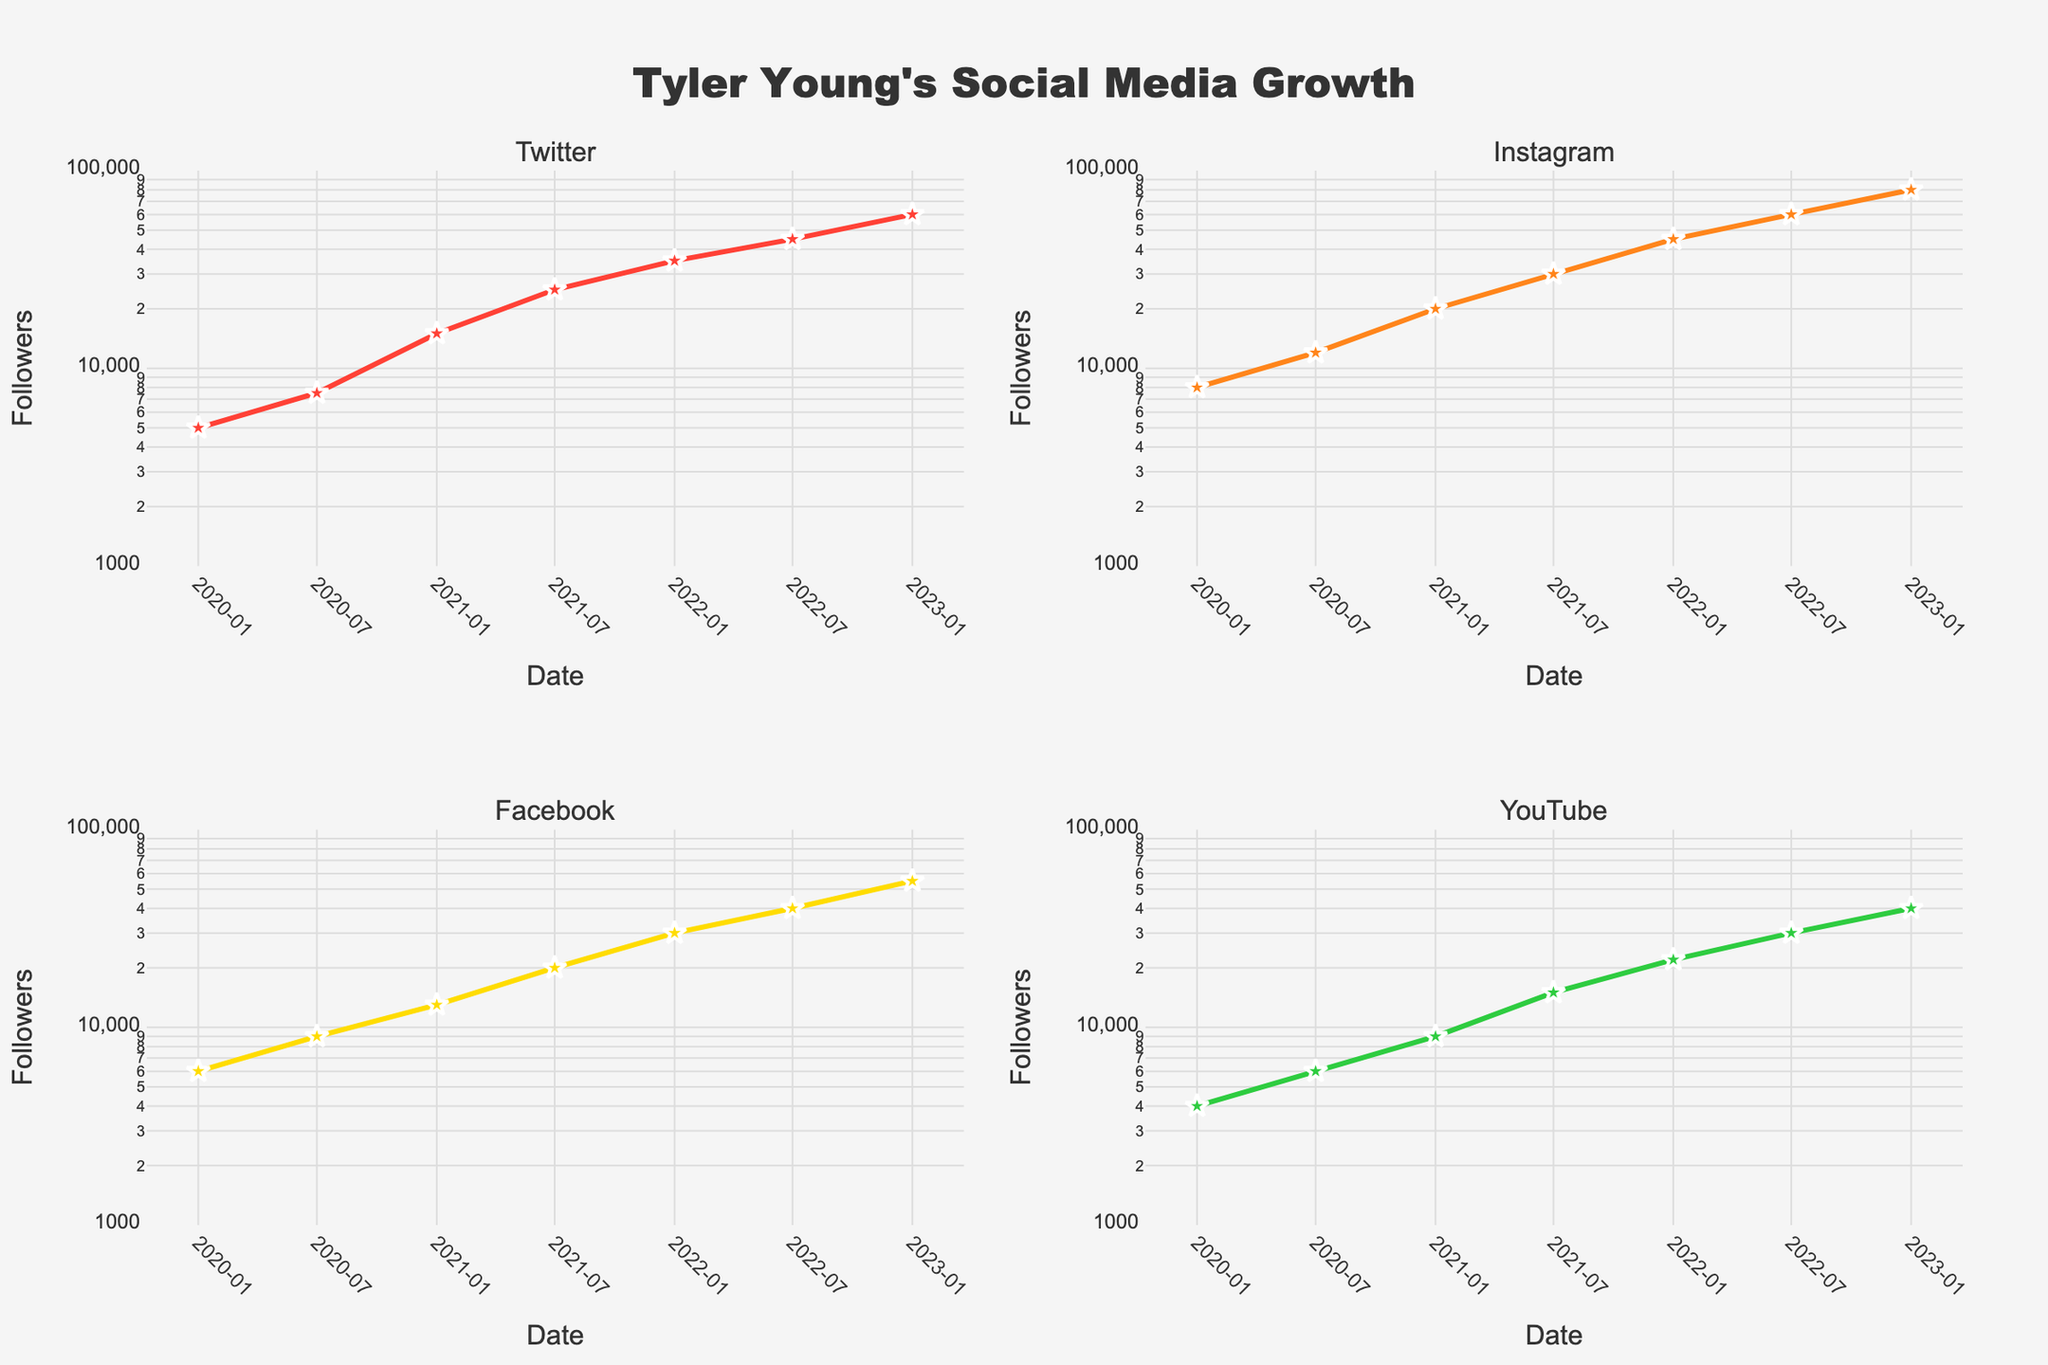How many social media platforms are tracked in the figure? The figure includes subplots for each social media platform, and there are four subplot titles visible on the figure.
Answer: Four Which platform had the highest number of followers in January 2023? By looking at the rightmost data points for January 2023 across all subplots and comparing the values, Instagram had the highest number with 80,000 followers.
Answer: Instagram How has Twitter follower growth trended from 2020 to 2023? Observing the subplot for Twitter, the follower count increased from 5,000 in January 2020 to 60,000 in January 2023. The growth is roughly exponential, as the Y-axis is in logarithmic scale.
Answer: Exponential growth Between Facebook and YouTube, which platform had a faster growth rate from 2021 to 2022? Comparing 2021 to 2022 data points in the respective subplots, Facebook followers increased from 13,000 to 30,000, while YouTube followers increased from 9,000 to 22,000. Calculating the growth rates: Facebook's rate is (30,000 - 13,000)/13,000 ≈ 1.31, and YouTube's rate is (22,000 - 9,000)/9,000 ≈ 1.44. Therefore, YouTube had a faster growth rate.
Answer: YouTube What is the approximate total number of followers across all platforms in January 2022? Summing up the follower counts for January 2022 from each subplot: Twitter (35,000), Instagram (45,000), Facebook (30,000), and YouTube (22,000). Adding them gives 35,000 + 45,000 + 30,000 + 22,000 = 132,000.
Answer: 132,000 Which platform's followers grew by a factor of 3 between July 2020 and January 2023? To find the platforms with a tripling of followers, check each subplot. For Twitter: 7,500 in July 2020 to 60,000 in January 2023 (not tripled). For Instagram: 12,000 to 80,000 (more than tripled). For Facebook: 9,000 to 55,000 (more than tripled). For YouTube: 6,000 to 40,000 (more than tripled). None of the platforms had exactly tripled their followers; they all grew by more than a factor of 3.
Answer: None Did any platform show a linear growth trend on the log scale axis? On a log scale, linear growth appears as an exponential curve. Checking the subplots, Instagram appears to have a more consistent and straighter upward trajectory, indicating an exponential (linear on log) growth pattern.
Answer: Instagram Which platform experienced the greatest increase in followers from July 2022 to January 2023? Comparing the increase in follower counts between these two points: Twitter (45,000 to 60,000), Instagram (60,000 to 80,000), Facebook (40,000 to 55,000), YouTube (30,000 to 40,000). The largest increase is with Instagram, which gained 20,000 followers.
Answer: Instagram What was the average growth rate of followers for YouTube from January 2020 to January 2023? To find the average growth rate, divide the total increase in followers by the number of years. YouTube went from 4,000 followers to 40,000: (40,000 - 4,000)/4,000 = 9 over 3 years. The average yearly growth rate is 9 / 3 ≈ 3 times per year.
Answer: 3 times per year 